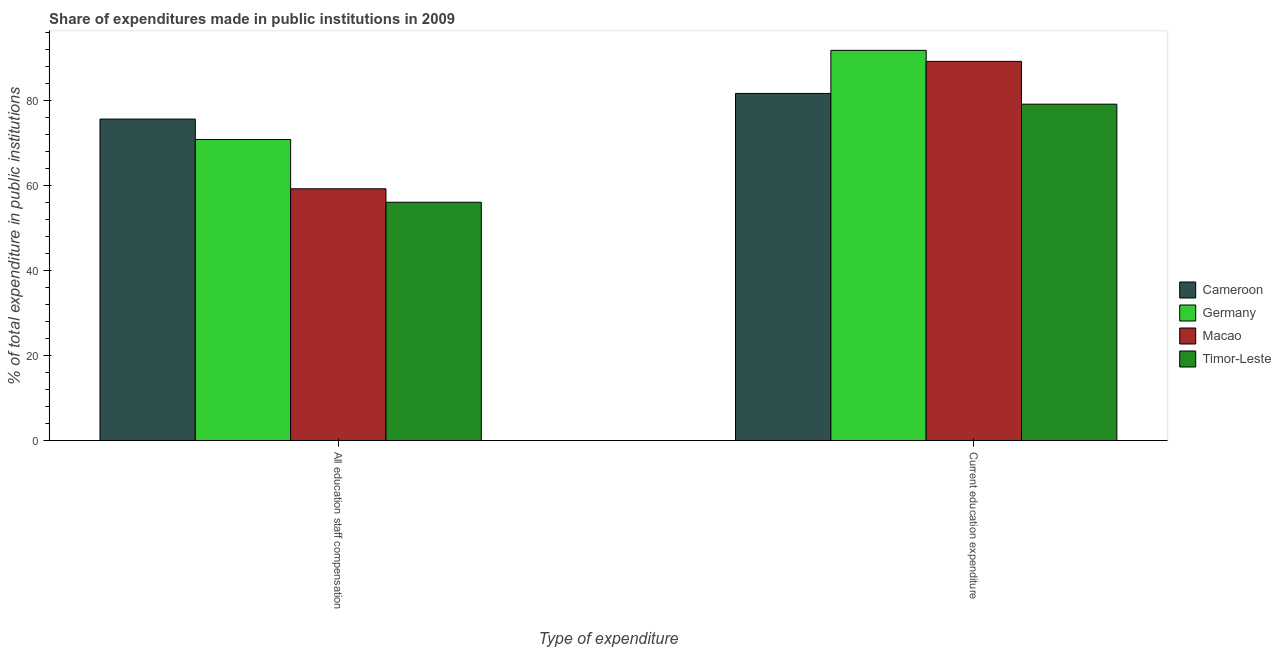How many different coloured bars are there?
Give a very brief answer. 4. Are the number of bars per tick equal to the number of legend labels?
Your answer should be compact. Yes. How many bars are there on the 2nd tick from the left?
Give a very brief answer. 4. What is the label of the 2nd group of bars from the left?
Your response must be concise. Current education expenditure. What is the expenditure in education in Germany?
Your answer should be very brief. 91.82. Across all countries, what is the maximum expenditure in education?
Give a very brief answer. 91.82. Across all countries, what is the minimum expenditure in staff compensation?
Make the answer very short. 56.07. In which country was the expenditure in education maximum?
Keep it short and to the point. Germany. In which country was the expenditure in staff compensation minimum?
Your answer should be very brief. Timor-Leste. What is the total expenditure in staff compensation in the graph?
Keep it short and to the point. 261.8. What is the difference between the expenditure in education in Timor-Leste and that in Macao?
Your answer should be very brief. -10.07. What is the difference between the expenditure in staff compensation in Cameroon and the expenditure in education in Macao?
Offer a very short reply. -13.57. What is the average expenditure in education per country?
Your answer should be very brief. 85.47. What is the difference between the expenditure in staff compensation and expenditure in education in Germany?
Keep it short and to the point. -20.98. What is the ratio of the expenditure in education in Germany to that in Timor-Leste?
Keep it short and to the point. 1.16. In how many countries, is the expenditure in staff compensation greater than the average expenditure in staff compensation taken over all countries?
Your response must be concise. 2. What does the 2nd bar from the right in All education staff compensation represents?
Your response must be concise. Macao. Are all the bars in the graph horizontal?
Ensure brevity in your answer.  No. How many countries are there in the graph?
Offer a terse response. 4. What is the difference between two consecutive major ticks on the Y-axis?
Keep it short and to the point. 20. Are the values on the major ticks of Y-axis written in scientific E-notation?
Keep it short and to the point. No. Does the graph contain any zero values?
Offer a terse response. No. Does the graph contain grids?
Offer a terse response. No. How are the legend labels stacked?
Your response must be concise. Vertical. What is the title of the graph?
Give a very brief answer. Share of expenditures made in public institutions in 2009. Does "Senegal" appear as one of the legend labels in the graph?
Offer a very short reply. No. What is the label or title of the X-axis?
Your answer should be compact. Type of expenditure. What is the label or title of the Y-axis?
Offer a terse response. % of total expenditure in public institutions. What is the % of total expenditure in public institutions of Cameroon in All education staff compensation?
Ensure brevity in your answer.  75.65. What is the % of total expenditure in public institutions of Germany in All education staff compensation?
Offer a very short reply. 70.84. What is the % of total expenditure in public institutions in Macao in All education staff compensation?
Make the answer very short. 59.24. What is the % of total expenditure in public institutions of Timor-Leste in All education staff compensation?
Keep it short and to the point. 56.07. What is the % of total expenditure in public institutions of Cameroon in Current education expenditure?
Give a very brief answer. 81.68. What is the % of total expenditure in public institutions of Germany in Current education expenditure?
Make the answer very short. 91.82. What is the % of total expenditure in public institutions of Macao in Current education expenditure?
Make the answer very short. 89.22. What is the % of total expenditure in public institutions of Timor-Leste in Current education expenditure?
Give a very brief answer. 79.15. Across all Type of expenditure, what is the maximum % of total expenditure in public institutions in Cameroon?
Provide a succinct answer. 81.68. Across all Type of expenditure, what is the maximum % of total expenditure in public institutions in Germany?
Your answer should be very brief. 91.82. Across all Type of expenditure, what is the maximum % of total expenditure in public institutions of Macao?
Your response must be concise. 89.22. Across all Type of expenditure, what is the maximum % of total expenditure in public institutions in Timor-Leste?
Keep it short and to the point. 79.15. Across all Type of expenditure, what is the minimum % of total expenditure in public institutions in Cameroon?
Offer a very short reply. 75.65. Across all Type of expenditure, what is the minimum % of total expenditure in public institutions in Germany?
Offer a very short reply. 70.84. Across all Type of expenditure, what is the minimum % of total expenditure in public institutions of Macao?
Make the answer very short. 59.24. Across all Type of expenditure, what is the minimum % of total expenditure in public institutions in Timor-Leste?
Provide a short and direct response. 56.07. What is the total % of total expenditure in public institutions in Cameroon in the graph?
Your answer should be very brief. 157.33. What is the total % of total expenditure in public institutions in Germany in the graph?
Your answer should be compact. 162.66. What is the total % of total expenditure in public institutions in Macao in the graph?
Offer a very short reply. 148.46. What is the total % of total expenditure in public institutions in Timor-Leste in the graph?
Offer a terse response. 135.22. What is the difference between the % of total expenditure in public institutions of Cameroon in All education staff compensation and that in Current education expenditure?
Offer a very short reply. -6.03. What is the difference between the % of total expenditure in public institutions in Germany in All education staff compensation and that in Current education expenditure?
Keep it short and to the point. -20.98. What is the difference between the % of total expenditure in public institutions in Macao in All education staff compensation and that in Current education expenditure?
Offer a very short reply. -29.98. What is the difference between the % of total expenditure in public institutions in Timor-Leste in All education staff compensation and that in Current education expenditure?
Offer a very short reply. -23.08. What is the difference between the % of total expenditure in public institutions in Cameroon in All education staff compensation and the % of total expenditure in public institutions in Germany in Current education expenditure?
Keep it short and to the point. -16.17. What is the difference between the % of total expenditure in public institutions in Cameroon in All education staff compensation and the % of total expenditure in public institutions in Macao in Current education expenditure?
Your response must be concise. -13.57. What is the difference between the % of total expenditure in public institutions of Cameroon in All education staff compensation and the % of total expenditure in public institutions of Timor-Leste in Current education expenditure?
Your response must be concise. -3.5. What is the difference between the % of total expenditure in public institutions of Germany in All education staff compensation and the % of total expenditure in public institutions of Macao in Current education expenditure?
Offer a very short reply. -18.38. What is the difference between the % of total expenditure in public institutions in Germany in All education staff compensation and the % of total expenditure in public institutions in Timor-Leste in Current education expenditure?
Offer a very short reply. -8.31. What is the difference between the % of total expenditure in public institutions in Macao in All education staff compensation and the % of total expenditure in public institutions in Timor-Leste in Current education expenditure?
Your response must be concise. -19.91. What is the average % of total expenditure in public institutions of Cameroon per Type of expenditure?
Ensure brevity in your answer.  78.66. What is the average % of total expenditure in public institutions of Germany per Type of expenditure?
Your response must be concise. 81.33. What is the average % of total expenditure in public institutions of Macao per Type of expenditure?
Provide a short and direct response. 74.23. What is the average % of total expenditure in public institutions of Timor-Leste per Type of expenditure?
Make the answer very short. 67.61. What is the difference between the % of total expenditure in public institutions of Cameroon and % of total expenditure in public institutions of Germany in All education staff compensation?
Keep it short and to the point. 4.81. What is the difference between the % of total expenditure in public institutions of Cameroon and % of total expenditure in public institutions of Macao in All education staff compensation?
Keep it short and to the point. 16.41. What is the difference between the % of total expenditure in public institutions of Cameroon and % of total expenditure in public institutions of Timor-Leste in All education staff compensation?
Offer a terse response. 19.58. What is the difference between the % of total expenditure in public institutions of Germany and % of total expenditure in public institutions of Macao in All education staff compensation?
Your answer should be compact. 11.6. What is the difference between the % of total expenditure in public institutions of Germany and % of total expenditure in public institutions of Timor-Leste in All education staff compensation?
Provide a succinct answer. 14.77. What is the difference between the % of total expenditure in public institutions of Macao and % of total expenditure in public institutions of Timor-Leste in All education staff compensation?
Keep it short and to the point. 3.17. What is the difference between the % of total expenditure in public institutions of Cameroon and % of total expenditure in public institutions of Germany in Current education expenditure?
Provide a succinct answer. -10.14. What is the difference between the % of total expenditure in public institutions in Cameroon and % of total expenditure in public institutions in Macao in Current education expenditure?
Provide a succinct answer. -7.54. What is the difference between the % of total expenditure in public institutions in Cameroon and % of total expenditure in public institutions in Timor-Leste in Current education expenditure?
Offer a very short reply. 2.53. What is the difference between the % of total expenditure in public institutions of Germany and % of total expenditure in public institutions of Macao in Current education expenditure?
Ensure brevity in your answer.  2.6. What is the difference between the % of total expenditure in public institutions in Germany and % of total expenditure in public institutions in Timor-Leste in Current education expenditure?
Keep it short and to the point. 12.67. What is the difference between the % of total expenditure in public institutions in Macao and % of total expenditure in public institutions in Timor-Leste in Current education expenditure?
Make the answer very short. 10.07. What is the ratio of the % of total expenditure in public institutions in Cameroon in All education staff compensation to that in Current education expenditure?
Offer a terse response. 0.93. What is the ratio of the % of total expenditure in public institutions of Germany in All education staff compensation to that in Current education expenditure?
Your answer should be compact. 0.77. What is the ratio of the % of total expenditure in public institutions in Macao in All education staff compensation to that in Current education expenditure?
Give a very brief answer. 0.66. What is the ratio of the % of total expenditure in public institutions of Timor-Leste in All education staff compensation to that in Current education expenditure?
Offer a terse response. 0.71. What is the difference between the highest and the second highest % of total expenditure in public institutions in Cameroon?
Provide a succinct answer. 6.03. What is the difference between the highest and the second highest % of total expenditure in public institutions of Germany?
Your answer should be very brief. 20.98. What is the difference between the highest and the second highest % of total expenditure in public institutions in Macao?
Provide a short and direct response. 29.98. What is the difference between the highest and the second highest % of total expenditure in public institutions in Timor-Leste?
Your answer should be very brief. 23.08. What is the difference between the highest and the lowest % of total expenditure in public institutions in Cameroon?
Offer a very short reply. 6.03. What is the difference between the highest and the lowest % of total expenditure in public institutions of Germany?
Provide a short and direct response. 20.98. What is the difference between the highest and the lowest % of total expenditure in public institutions of Macao?
Your answer should be compact. 29.98. What is the difference between the highest and the lowest % of total expenditure in public institutions of Timor-Leste?
Your answer should be compact. 23.08. 